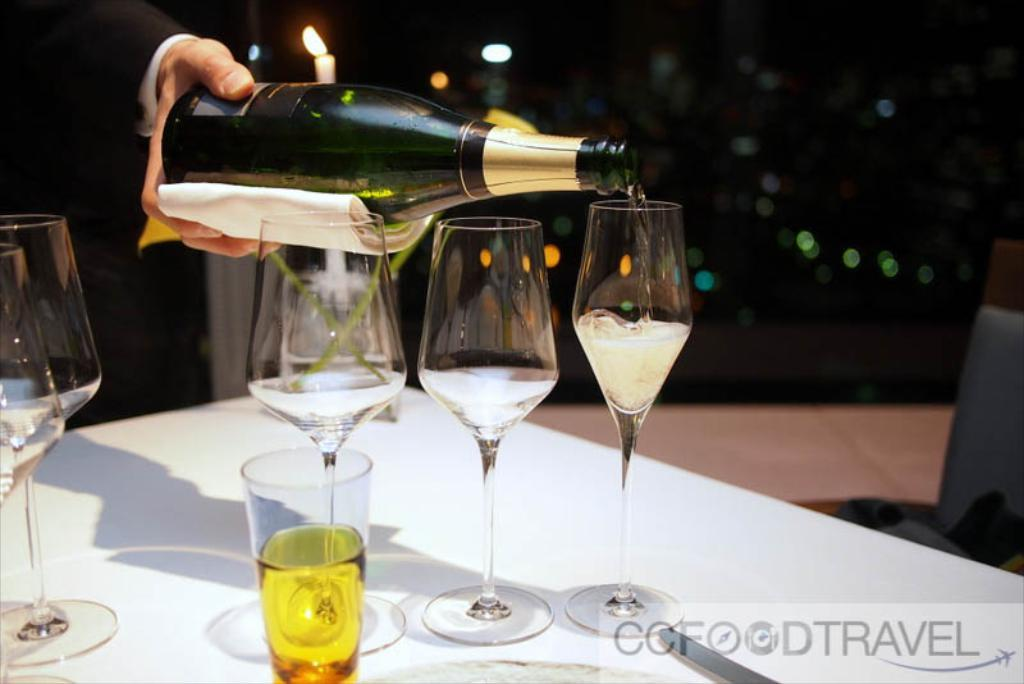How many glasses are on the table in the image? There are four big glasses and one small glass on the table, making a total of five glasses. What is the person in the image doing? The person is pouring a drink into one of the glasses. What can be inferred about the time of day based on the background of the image? The background of the image appears to be dark, suggesting it is nighttime. What type of celery is being used as a stirrer in the small glass? There is no celery present in the image, and therefore it cannot be used as a stirrer in any of the glasses. 